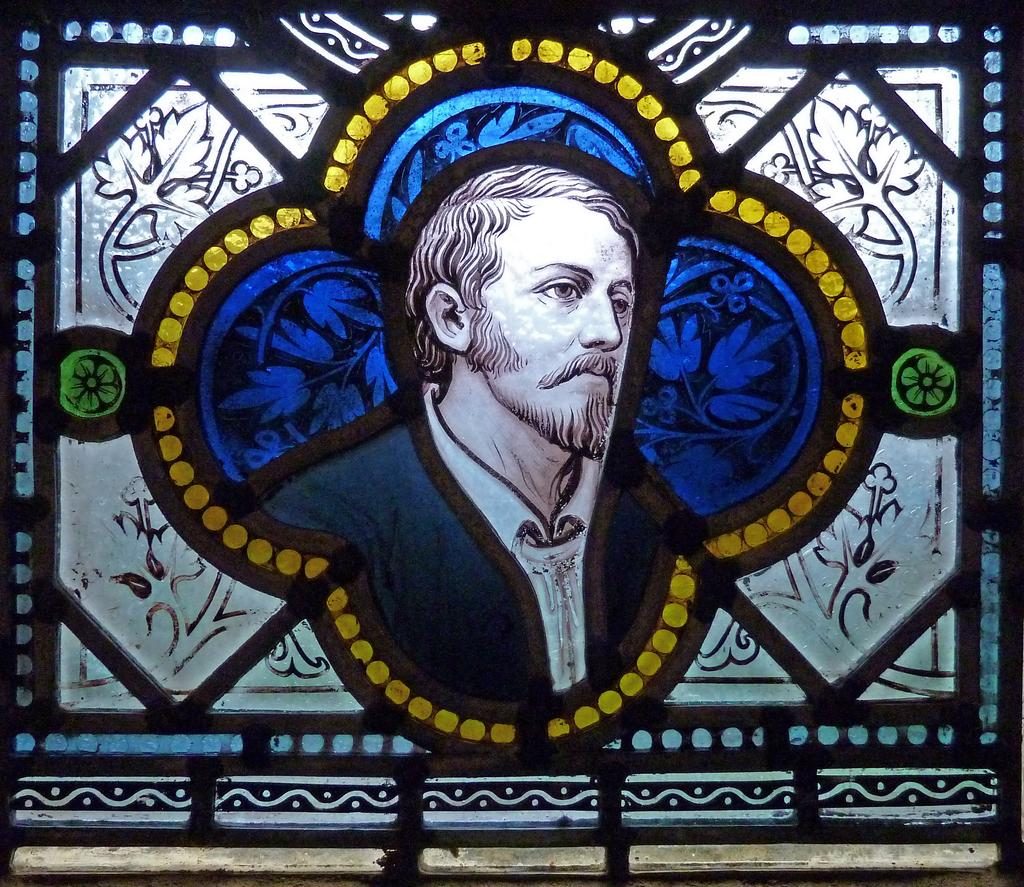Who or what is present in the image? There is a person in the image. Can you describe the setting or context of the person in the image? The person is in a frame. How long does the song last in the image? There is no song present in the image, so it cannot be determined how long it lasts. 